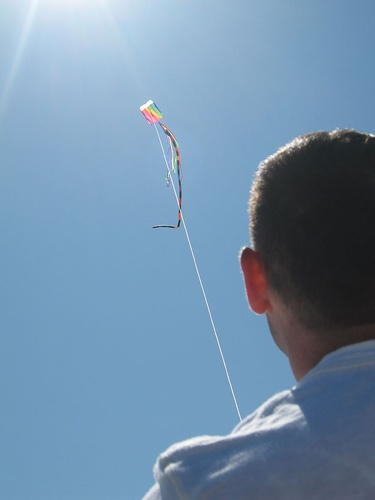Describe the objects in this image and their specific colors. I can see people in lightblue, black, gray, and blue tones and kite in lightblue, darkgray, lightpink, and white tones in this image. 